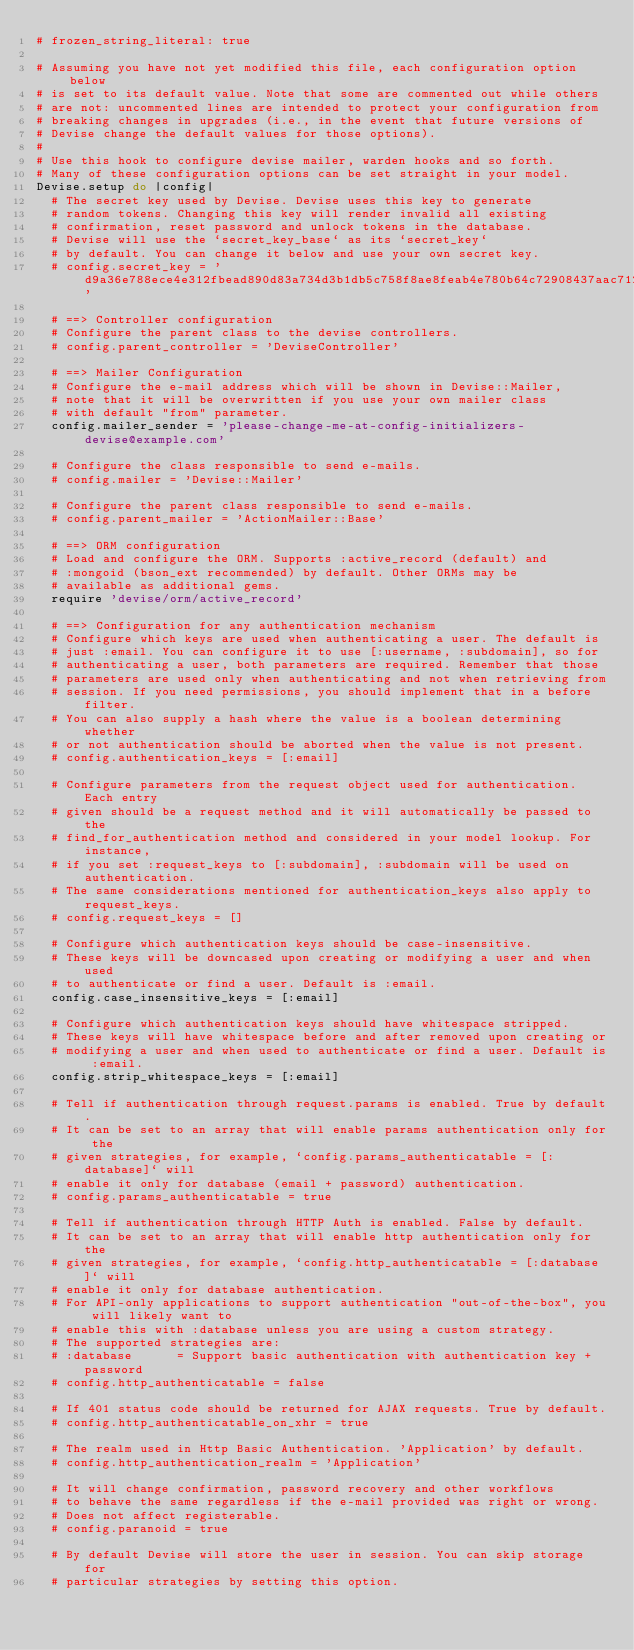<code> <loc_0><loc_0><loc_500><loc_500><_Ruby_># frozen_string_literal: true

# Assuming you have not yet modified this file, each configuration option below
# is set to its default value. Note that some are commented out while others
# are not: uncommented lines are intended to protect your configuration from
# breaking changes in upgrades (i.e., in the event that future versions of
# Devise change the default values for those options).
#
# Use this hook to configure devise mailer, warden hooks and so forth.
# Many of these configuration options can be set straight in your model.
Devise.setup do |config|
  # The secret key used by Devise. Devise uses this key to generate
  # random tokens. Changing this key will render invalid all existing
  # confirmation, reset password and unlock tokens in the database.
  # Devise will use the `secret_key_base` as its `secret_key`
  # by default. You can change it below and use your own secret key.
  # config.secret_key = 'd9a36e788ece4e312fbead890d83a734d3b1db5c758f8ae8feab4e780b64c72908437aac712e8b018ec680f8cf60403eecbfa55216d71ea845c1e6d90300a006'

  # ==> Controller configuration
  # Configure the parent class to the devise controllers.
  # config.parent_controller = 'DeviseController'

  # ==> Mailer Configuration
  # Configure the e-mail address which will be shown in Devise::Mailer,
  # note that it will be overwritten if you use your own mailer class
  # with default "from" parameter.
  config.mailer_sender = 'please-change-me-at-config-initializers-devise@example.com'

  # Configure the class responsible to send e-mails.
  # config.mailer = 'Devise::Mailer'

  # Configure the parent class responsible to send e-mails.
  # config.parent_mailer = 'ActionMailer::Base'

  # ==> ORM configuration
  # Load and configure the ORM. Supports :active_record (default) and
  # :mongoid (bson_ext recommended) by default. Other ORMs may be
  # available as additional gems.
  require 'devise/orm/active_record'

  # ==> Configuration for any authentication mechanism
  # Configure which keys are used when authenticating a user. The default is
  # just :email. You can configure it to use [:username, :subdomain], so for
  # authenticating a user, both parameters are required. Remember that those
  # parameters are used only when authenticating and not when retrieving from
  # session. If you need permissions, you should implement that in a before filter.
  # You can also supply a hash where the value is a boolean determining whether
  # or not authentication should be aborted when the value is not present.
  # config.authentication_keys = [:email]

  # Configure parameters from the request object used for authentication. Each entry
  # given should be a request method and it will automatically be passed to the
  # find_for_authentication method and considered in your model lookup. For instance,
  # if you set :request_keys to [:subdomain], :subdomain will be used on authentication.
  # The same considerations mentioned for authentication_keys also apply to request_keys.
  # config.request_keys = []

  # Configure which authentication keys should be case-insensitive.
  # These keys will be downcased upon creating or modifying a user and when used
  # to authenticate or find a user. Default is :email.
  config.case_insensitive_keys = [:email]

  # Configure which authentication keys should have whitespace stripped.
  # These keys will have whitespace before and after removed upon creating or
  # modifying a user and when used to authenticate or find a user. Default is :email.
  config.strip_whitespace_keys = [:email]

  # Tell if authentication through request.params is enabled. True by default.
  # It can be set to an array that will enable params authentication only for the
  # given strategies, for example, `config.params_authenticatable = [:database]` will
  # enable it only for database (email + password) authentication.
  # config.params_authenticatable = true

  # Tell if authentication through HTTP Auth is enabled. False by default.
  # It can be set to an array that will enable http authentication only for the
  # given strategies, for example, `config.http_authenticatable = [:database]` will
  # enable it only for database authentication.
  # For API-only applications to support authentication "out-of-the-box", you will likely want to
  # enable this with :database unless you are using a custom strategy.
  # The supported strategies are:
  # :database      = Support basic authentication with authentication key + password
  # config.http_authenticatable = false

  # If 401 status code should be returned for AJAX requests. True by default.
  # config.http_authenticatable_on_xhr = true

  # The realm used in Http Basic Authentication. 'Application' by default.
  # config.http_authentication_realm = 'Application'

  # It will change confirmation, password recovery and other workflows
  # to behave the same regardless if the e-mail provided was right or wrong.
  # Does not affect registerable.
  # config.paranoid = true

  # By default Devise will store the user in session. You can skip storage for
  # particular strategies by setting this option.</code> 